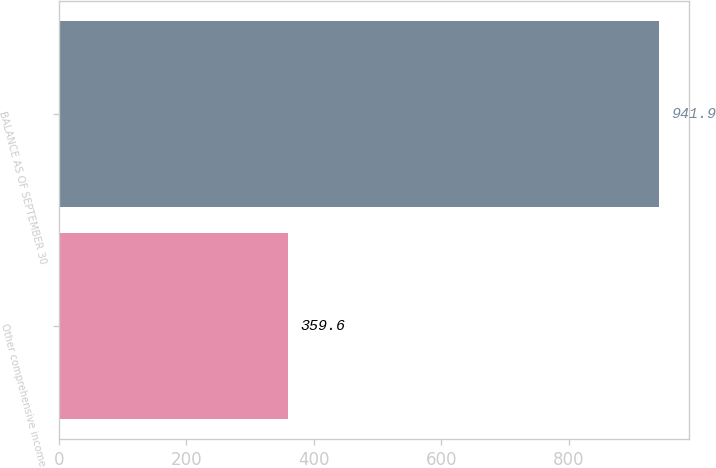Convert chart. <chart><loc_0><loc_0><loc_500><loc_500><bar_chart><fcel>Other comprehensive income<fcel>BALANCE AS OF SEPTEMBER 30<nl><fcel>359.6<fcel>941.9<nl></chart> 